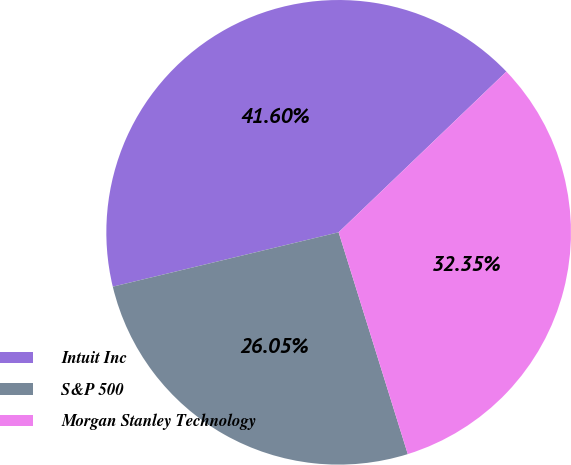Convert chart. <chart><loc_0><loc_0><loc_500><loc_500><pie_chart><fcel>Intuit Inc<fcel>S&P 500<fcel>Morgan Stanley Technology<nl><fcel>41.6%<fcel>26.05%<fcel>32.35%<nl></chart> 